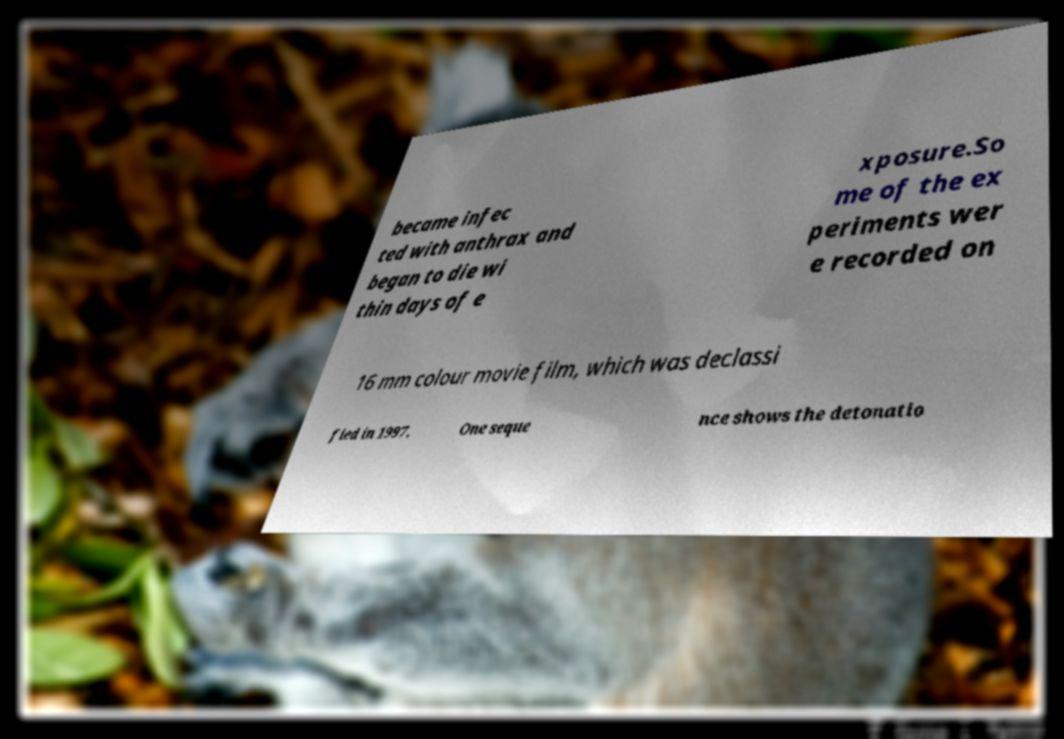Could you extract and type out the text from this image? became infec ted with anthrax and began to die wi thin days of e xposure.So me of the ex periments wer e recorded on 16 mm colour movie film, which was declassi fied in 1997. One seque nce shows the detonatio 